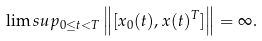<formula> <loc_0><loc_0><loc_500><loc_500>\lim s u p _ { 0 \leq t < T } \left \| [ x _ { 0 } ( t ) , x ( t ) ^ { T } ] \right \| = \infty .</formula> 